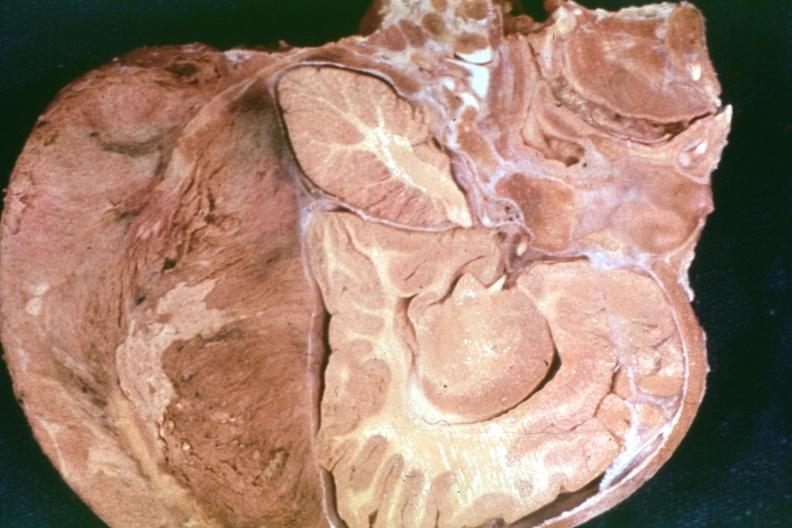s bone, calvarium present?
Answer the question using a single word or phrase. Yes 